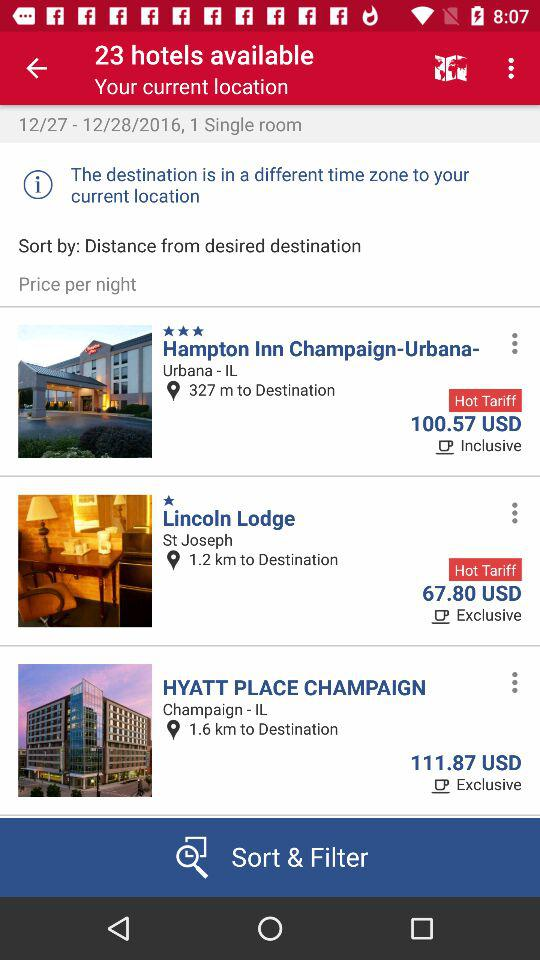How many hotels are available in the search results?
Answer the question using a single word or phrase. 23 